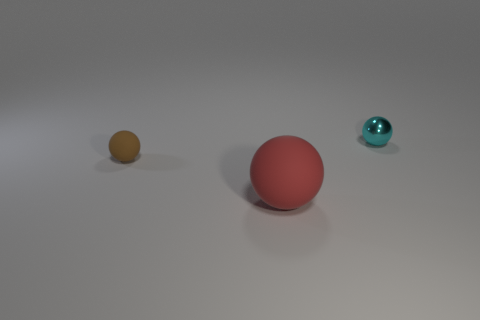The cyan ball is what size?
Ensure brevity in your answer.  Small. How many other objects are there of the same color as the large rubber object?
Keep it short and to the point. 0. Is the ball that is to the left of the red ball made of the same material as the big red ball?
Your response must be concise. Yes. Are there fewer small things that are right of the large red rubber object than red things that are on the left side of the small metal sphere?
Provide a succinct answer. No. How many other objects are the same material as the red ball?
Give a very brief answer. 1. There is a brown ball that is the same size as the cyan metal thing; what is it made of?
Ensure brevity in your answer.  Rubber. Is the number of tiny things that are in front of the metallic thing less than the number of gray cubes?
Provide a succinct answer. No. The tiny object that is in front of the object behind the tiny thing that is in front of the small cyan ball is what shape?
Give a very brief answer. Sphere. What size is the ball that is right of the big red ball?
Provide a succinct answer. Small. What shape is the other object that is the same size as the cyan metal thing?
Ensure brevity in your answer.  Sphere. 